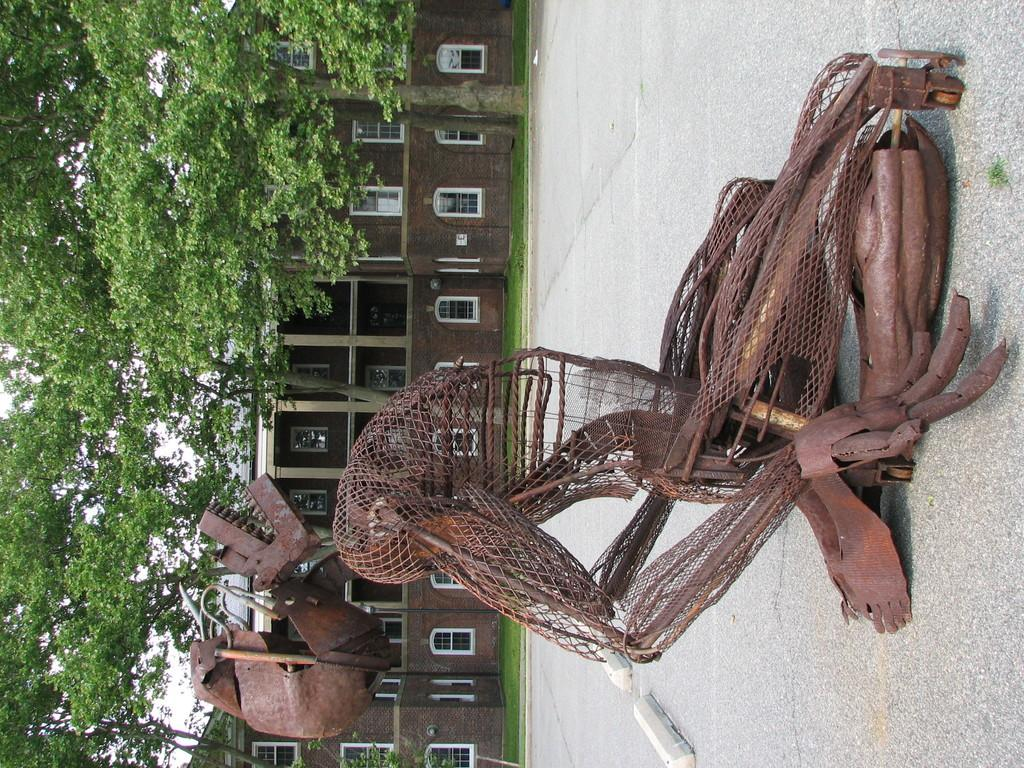What type of objects can be seen on the surface in the image? There are metal objects on the surface in the image. What structures are visible in the image? There are buildings visible in the image. What type of vegetation is present in the image? There are trees in the image. What color is the grass in the image? There is green grass in the image. How many babies are flying in the image? There are no babies or flights present in the image. What type of butter is spread on the trees in the image? There is no butter present in the image; it features trees and green grass. 